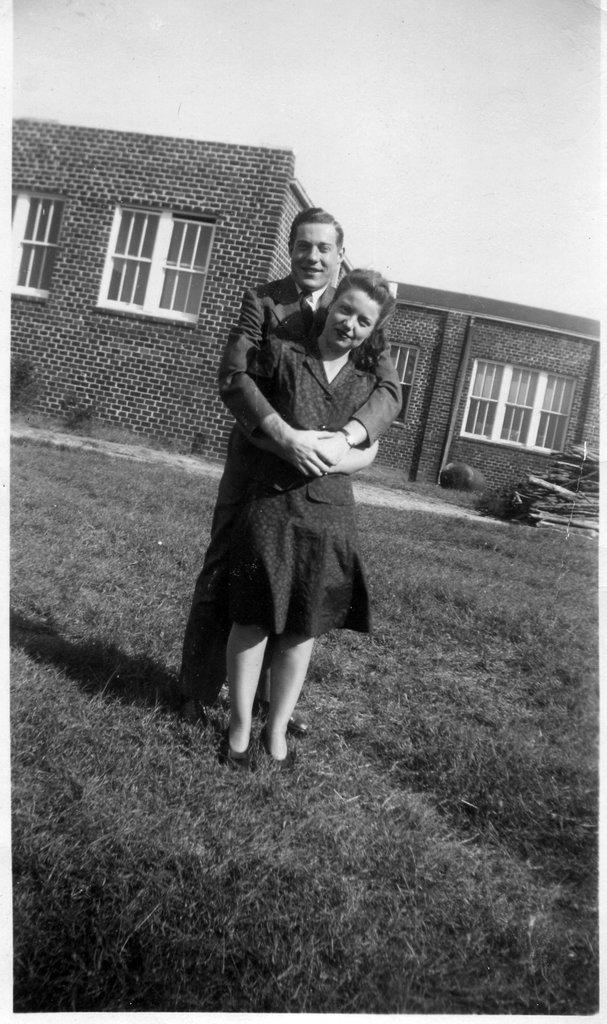Who is present in the image? There is a couple in the image. What is the setting of the image? The couple is standing on a greenery ground. What can be seen in the background of the image? There is a house behind the couple. What objects are present in the right corner of the image? There are wooden sticks in the right corner of the image. What reason does the couple give for wearing matching sweaters in the image? There is no mention of matching sweaters or any reason for wearing them in the image. 